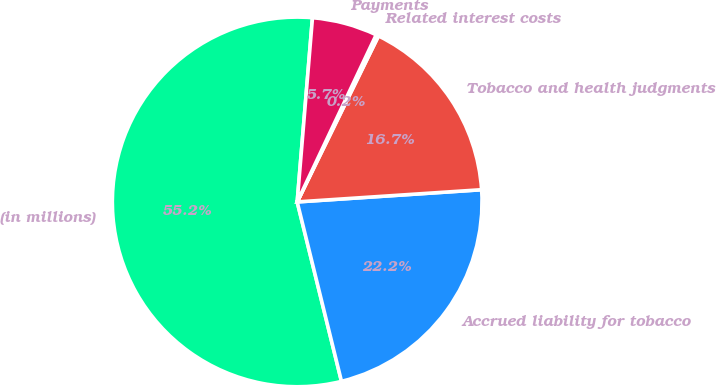Convert chart to OTSL. <chart><loc_0><loc_0><loc_500><loc_500><pie_chart><fcel>(in millions)<fcel>Accrued liability for tobacco<fcel>Tobacco and health judgments<fcel>Related interest costs<fcel>Payments<nl><fcel>55.17%<fcel>22.2%<fcel>16.7%<fcel>0.22%<fcel>5.71%<nl></chart> 